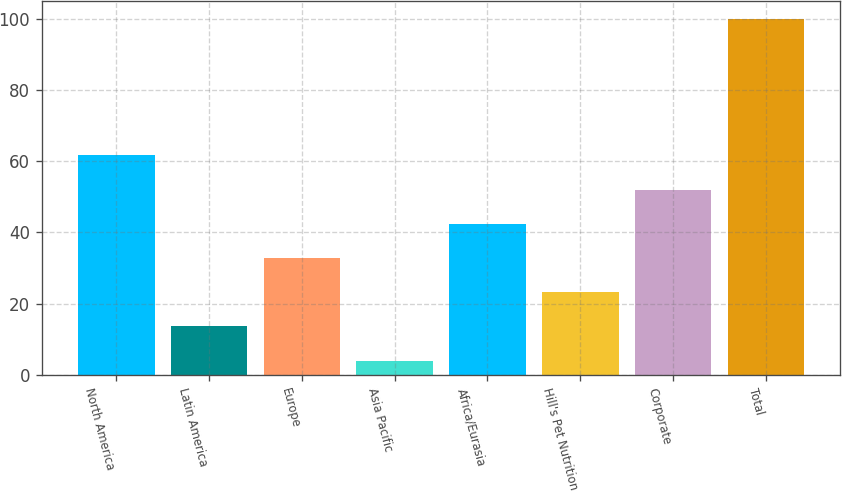<chart> <loc_0><loc_0><loc_500><loc_500><bar_chart><fcel>North America<fcel>Latin America<fcel>Europe<fcel>Asia Pacific<fcel>Africa/Eurasia<fcel>Hill's Pet Nutrition<fcel>Corporate<fcel>Total<nl><fcel>61.6<fcel>13.6<fcel>32.8<fcel>4<fcel>42.4<fcel>23.2<fcel>52<fcel>100<nl></chart> 